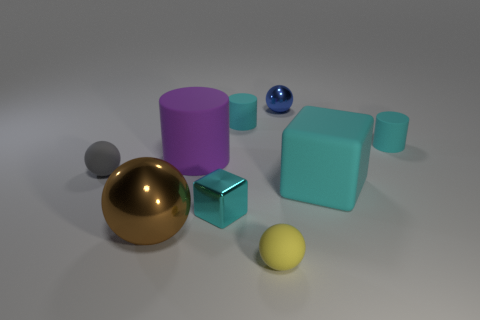Is the number of big cyan rubber cubes that are to the left of the purple thing less than the number of brown balls on the right side of the large cyan rubber block?
Your answer should be compact. No. What is the color of the small metal cube?
Your answer should be very brief. Cyan. Are there any large cylinders that have the same color as the large matte block?
Make the answer very short. No. There is a small metal thing right of the small cyan rubber cylinder that is on the left side of the tiny rubber object to the right of the small yellow thing; what is its shape?
Offer a very short reply. Sphere. There is a sphere right of the small yellow thing; what is its material?
Your response must be concise. Metal. There is a metallic sphere in front of the big thing that is to the right of the cyan rubber thing that is left of the yellow object; what is its size?
Provide a short and direct response. Large. Does the yellow object have the same size as the blue metal sphere to the right of the cyan metal cube?
Your answer should be very brief. Yes. What color is the small thing that is to the left of the tiny cyan metal block?
Give a very brief answer. Gray. What shape is the large thing that is the same color as the tiny shiny cube?
Ensure brevity in your answer.  Cube. There is a metal object in front of the tiny block; what shape is it?
Make the answer very short. Sphere. 